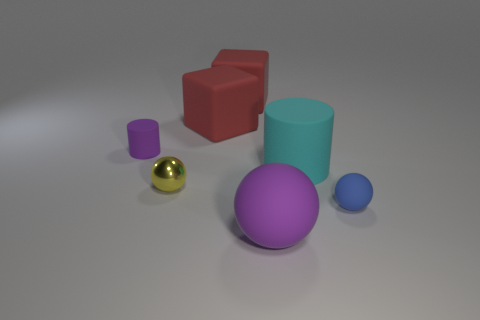Can you describe the lighting in this scene? Where might the light be coming from? The lighting in the scene is diffused, creating soft shadows and subtle highlights on the objects. This suggests an overhead light source, possibly out of frame, or a technique known as global illumination often used in rendering, which simulates the way light bounces off surfaces, creating a natural, realistic effect. 